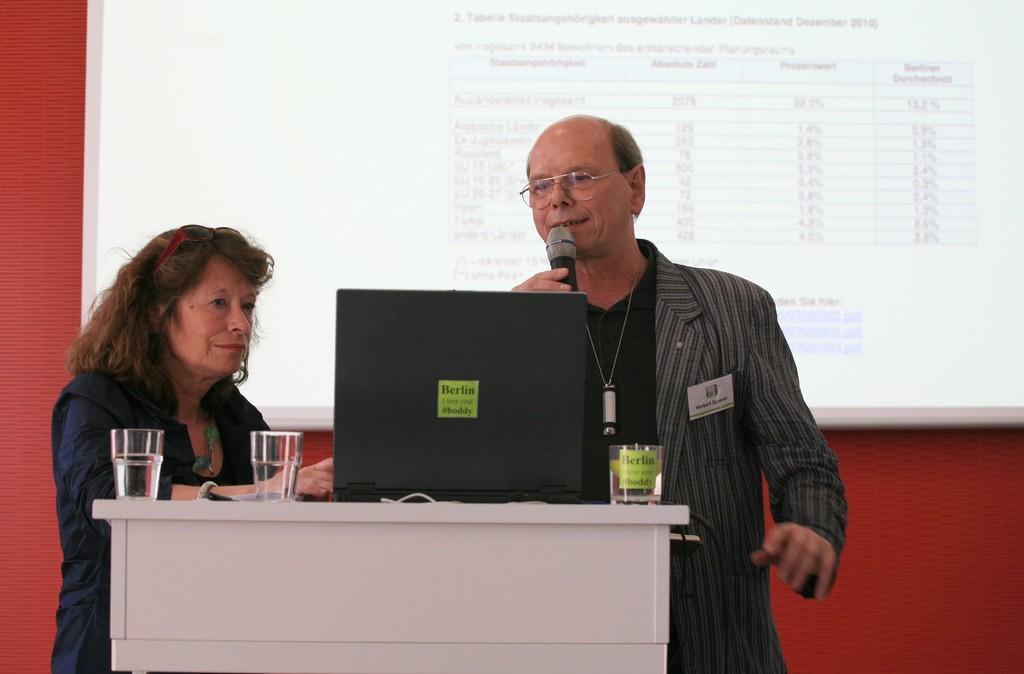Describe this image in one or two sentences. In this picture there is a woman and a man near the podium. On the podium there is a laptop and three glasses here. A man is holding a mic in his hand. In the background, there is a projector screen display here. 